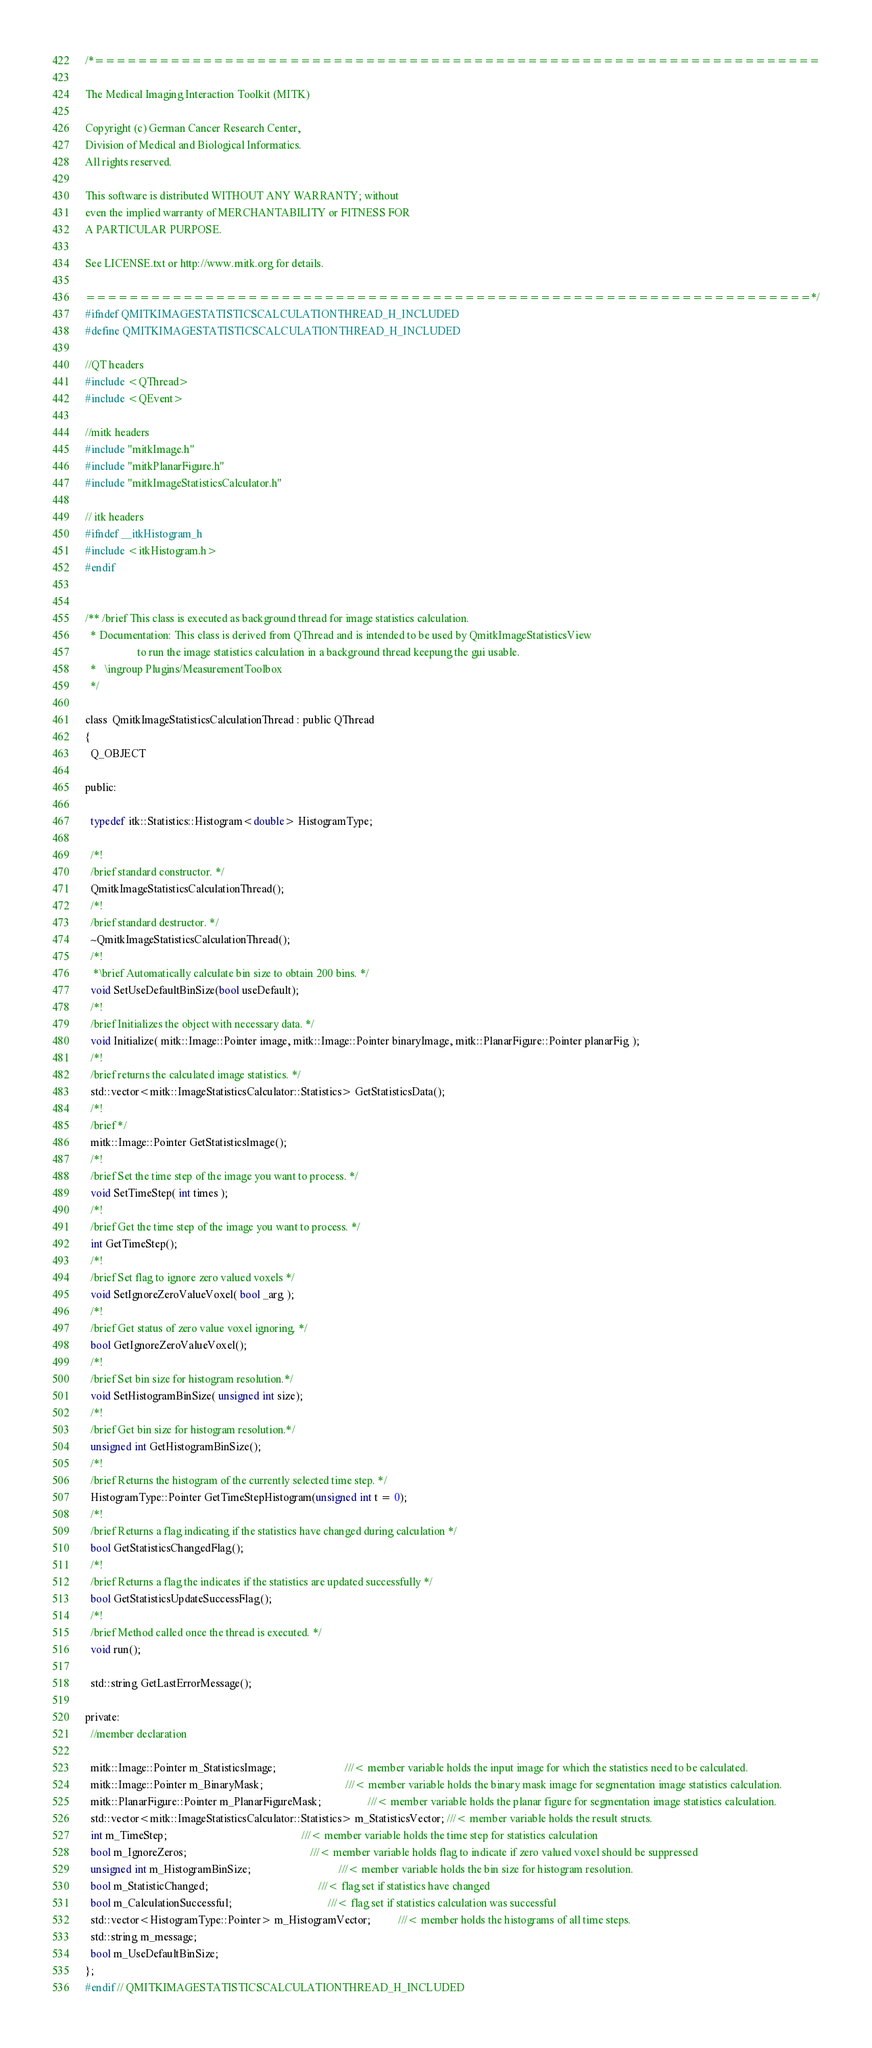<code> <loc_0><loc_0><loc_500><loc_500><_C_>/*===================================================================

The Medical Imaging Interaction Toolkit (MITK)

Copyright (c) German Cancer Research Center,
Division of Medical and Biological Informatics.
All rights reserved.

This software is distributed WITHOUT ANY WARRANTY; without
even the implied warranty of MERCHANTABILITY or FITNESS FOR
A PARTICULAR PURPOSE.

See LICENSE.txt or http://www.mitk.org for details.

===================================================================*/
#ifndef QMITKIMAGESTATISTICSCALCULATIONTHREAD_H_INCLUDED
#define QMITKIMAGESTATISTICSCALCULATIONTHREAD_H_INCLUDED

//QT headers
#include <QThread>
#include <QEvent>

//mitk headers
#include "mitkImage.h"
#include "mitkPlanarFigure.h"
#include "mitkImageStatisticsCalculator.h"

// itk headers
#ifndef __itkHistogram_h
#include <itkHistogram.h>
#endif


/** /brief This class is executed as background thread for image statistics calculation.
  * Documentation: This class is derived from QThread and is intended to be used by QmitkImageStatisticsView
                   to run the image statistics calculation in a background thread keepung the gui usable.
  *   \ingroup Plugins/MeasurementToolbox
  */

class  QmitkImageStatisticsCalculationThread : public QThread
{
  Q_OBJECT

public:

  typedef itk::Statistics::Histogram<double> HistogramType;

  /*!
  /brief standard constructor. */
  QmitkImageStatisticsCalculationThread();
  /*!
  /brief standard destructor. */
  ~QmitkImageStatisticsCalculationThread();
  /*!
   *\brief Automatically calculate bin size to obtain 200 bins. */
  void SetUseDefaultBinSize(bool useDefault);
  /*!
  /brief Initializes the object with necessary data. */
  void Initialize( mitk::Image::Pointer image, mitk::Image::Pointer binaryImage, mitk::PlanarFigure::Pointer planarFig );
  /*!
  /brief returns the calculated image statistics. */
  std::vector<mitk::ImageStatisticsCalculator::Statistics> GetStatisticsData();
  /*!
  /brief */
  mitk::Image::Pointer GetStatisticsImage();
  /*!
  /brief Set the time step of the image you want to process. */
  void SetTimeStep( int times );
  /*!
  /brief Get the time step of the image you want to process. */
  int GetTimeStep();
  /*!
  /brief Set flag to ignore zero valued voxels */
  void SetIgnoreZeroValueVoxel( bool _arg );
  /*!
  /brief Get status of zero value voxel ignoring. */
  bool GetIgnoreZeroValueVoxel();
  /*!
  /brief Set bin size for histogram resolution.*/
  void SetHistogramBinSize( unsigned int size);
  /*!
  /brief Get bin size for histogram resolution.*/
  unsigned int GetHistogramBinSize();
  /*!
  /brief Returns the histogram of the currently selected time step. */
  HistogramType::Pointer GetTimeStepHistogram(unsigned int t = 0);
  /*!
  /brief Returns a flag indicating if the statistics have changed during calculation */
  bool GetStatisticsChangedFlag();
  /*!
  /brief Returns a flag the indicates if the statistics are updated successfully */
  bool GetStatisticsUpdateSuccessFlag();
  /*!
  /brief Method called once the thread is executed. */
  void run();

  std::string GetLastErrorMessage();

private:
  //member declaration

  mitk::Image::Pointer m_StatisticsImage;                         ///< member variable holds the input image for which the statistics need to be calculated.
  mitk::Image::Pointer m_BinaryMask;                              ///< member variable holds the binary mask image for segmentation image statistics calculation.
  mitk::PlanarFigure::Pointer m_PlanarFigureMask;                 ///< member variable holds the planar figure for segmentation image statistics calculation.
  std::vector<mitk::ImageStatisticsCalculator::Statistics> m_StatisticsVector; ///< member variable holds the result structs.
  int m_TimeStep;                                                 ///< member variable holds the time step for statistics calculation
  bool m_IgnoreZeros;                                             ///< member variable holds flag to indicate if zero valued voxel should be suppressed
  unsigned int m_HistogramBinSize;                                ///< member variable holds the bin size for histogram resolution.
  bool m_StatisticChanged;                                        ///< flag set if statistics have changed
  bool m_CalculationSuccessful;                                   ///< flag set if statistics calculation was successful
  std::vector<HistogramType::Pointer> m_HistogramVector;          ///< member holds the histograms of all time steps.
  std::string m_message;
  bool m_UseDefaultBinSize;
};
#endif // QMITKIMAGESTATISTICSCALCULATIONTHREAD_H_INCLUDED
</code> 